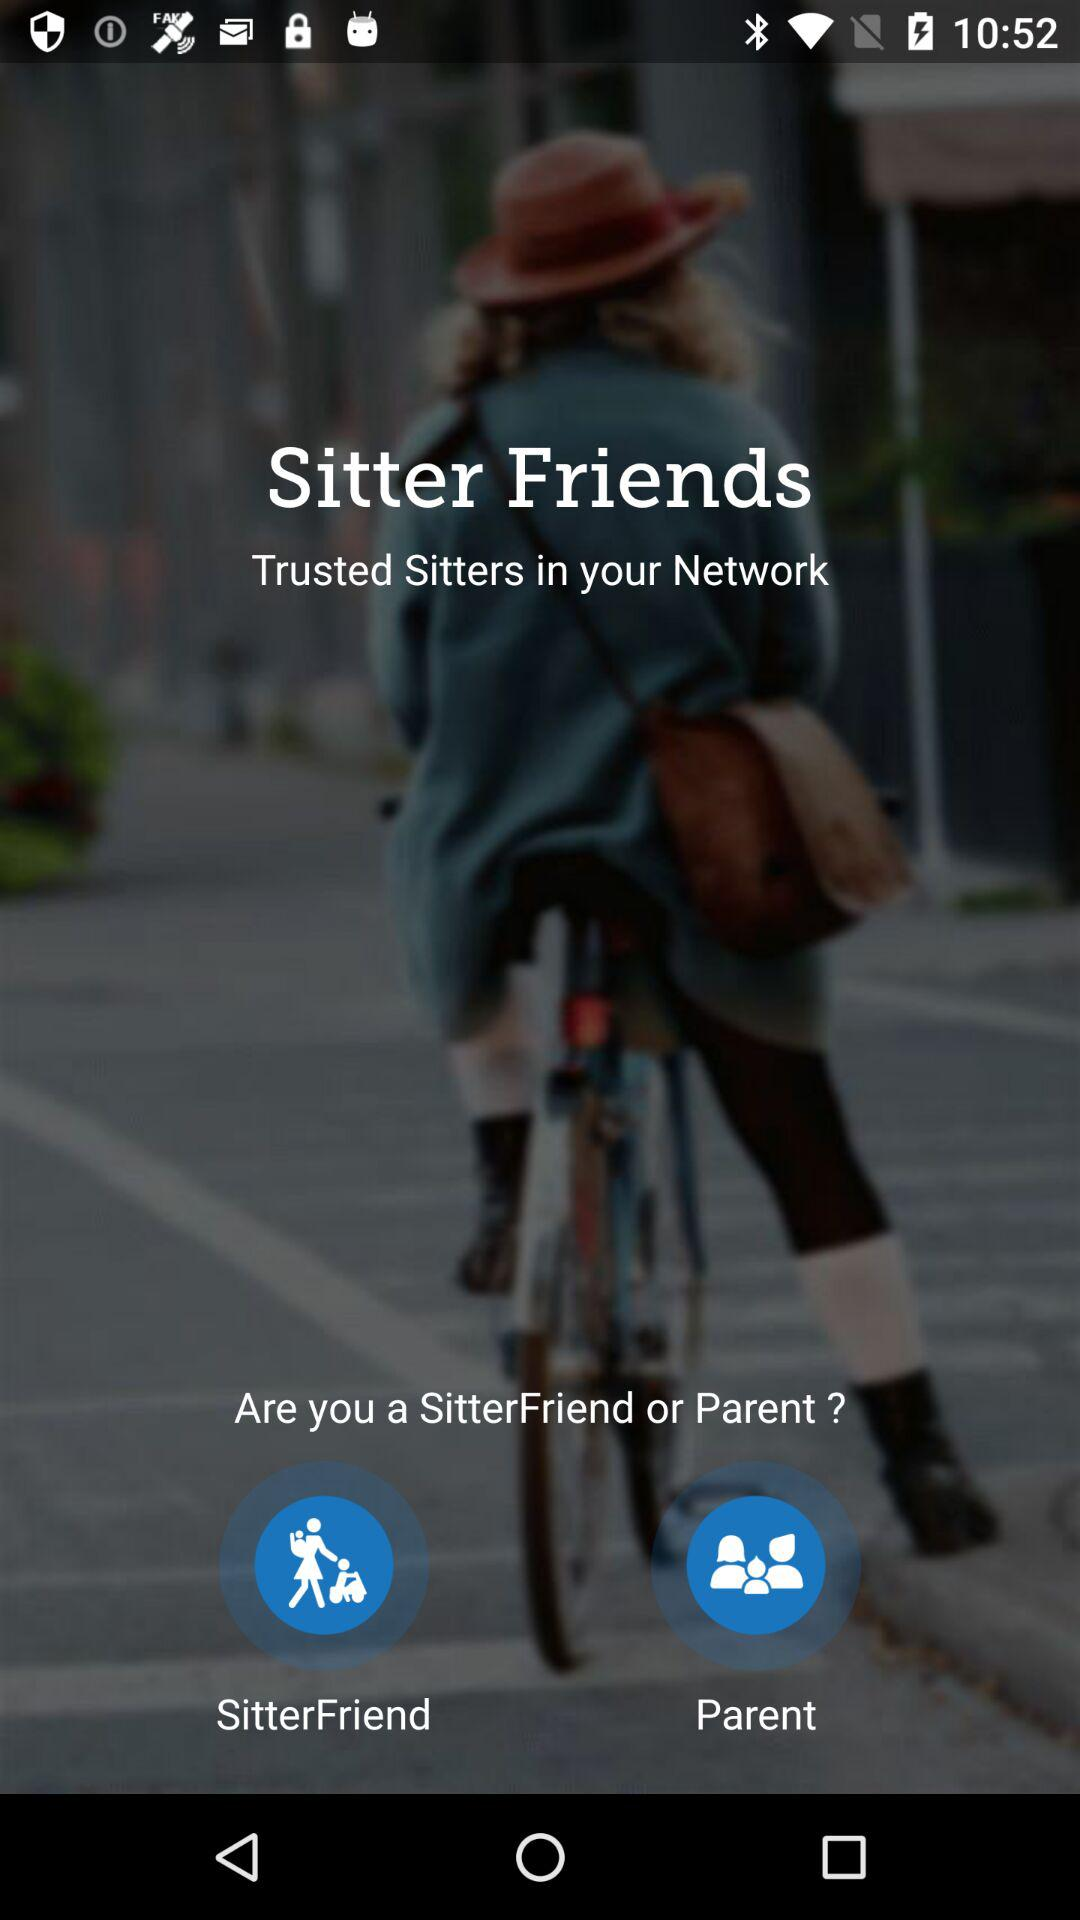Which option is selected?
When the provided information is insufficient, respond with <no answer>. <no answer> 